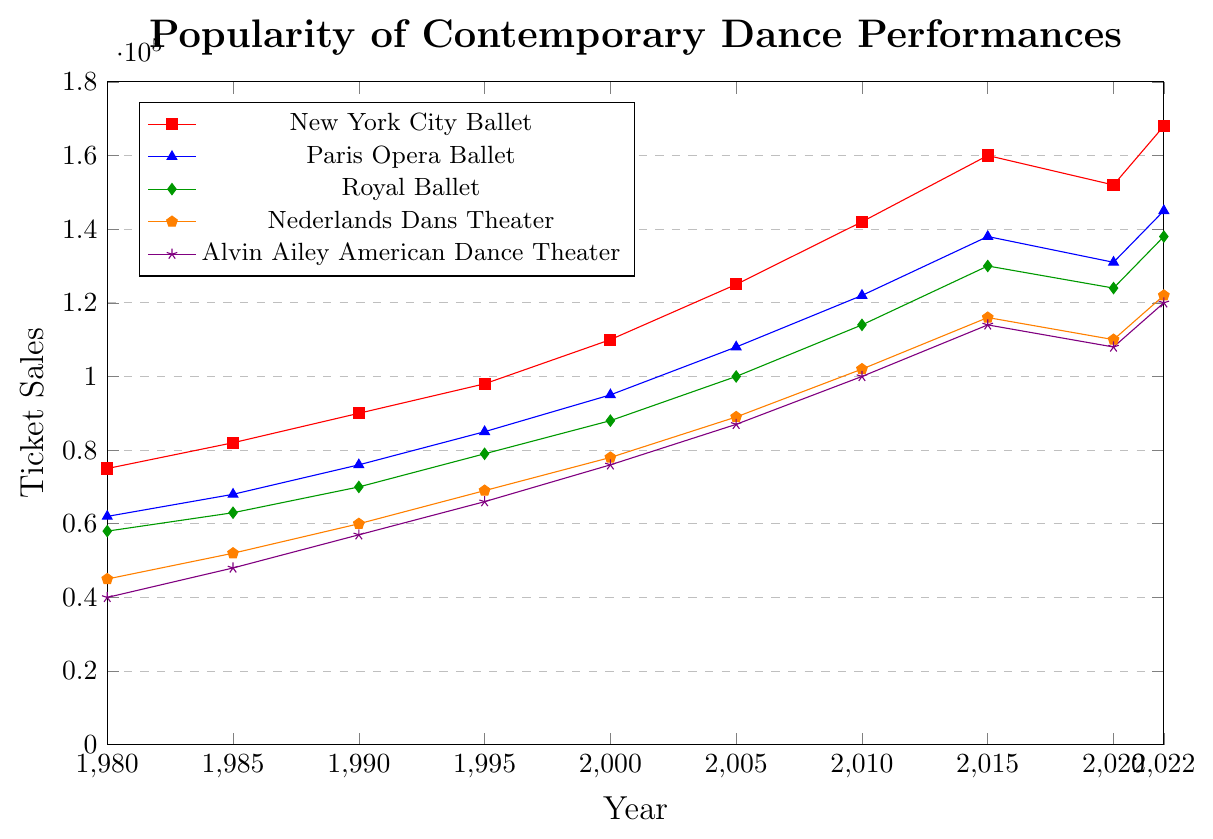What trend can be observed in ticket sales for the New York City Ballet from 1980 to 2022? From 1980 to 2022, the ticket sales for the New York City Ballet show a consistent upward trend except for a slight dip in 2020. Over the years, ticket sales have increased from 75,000 in 1980 to 168,000 in 2022.
Answer: Consistent upward trend Which theater had the highest ticket sales in 2022? Looking at the values for 2022, the New York City Ballet had the highest ticket sales at 168,000.
Answer: New York City Ballet By how much did ticket sales for the Paris Opera Ballet increase from 1980 to 2022? Ticket sales for the Paris Opera Ballet increased from 62,000 in 1980 to 145,000 in 2022. The increase is calculated as 145,000 - 62,000, which equals 83,000.
Answer: 83,000 What are the average ticket sales for Alvin Ailey American Dance Theater from 1980 to 2022? To find the average ticket sales, sum up all ticket sales from 1980 to 2022 (40,000 + 48,000 + 57,000 + 66,000 + 76,000 + 87,000 + 100,000 + 114,000 + 108,000 + 120,000) and divide by the number of years (10). The sum is 816,000, so the average is 816,000 / 10 = 81,600.
Answer: 81,600 Which theaters experienced a decrease in ticket sales from 2015 to 2020? Comparing the ticket sales from 2015 to 2020, the theaters that experienced a decrease are the New York City Ballet (160,000 to 152,000), Paris Opera Ballet (138,000 to 131,000), Royal Ballet (130,000 to 124,000), Nederlands Dans Theater (116,000 to 110,000), and Alvin Ailey American Dance Theater (114,000 to 108,000).
Answer: All theaters By what percentage did the Royal Ballet's ticket sales grow from 2000 to 2010? Ticket sales for the Royal Ballet grew from 88,000 in 2000 to 114,000 in 2010. The growth can be calculated as ((114,000 - 88,000) / 88,000) * 100 = 29.55%.
Answer: 29.55% Which theater’s ticket sales increased the most between 1980 and 2022? Comparing the increase in ticket sales from 1980 to 2022: 
- New York City Ballet: 168,000 - 75,000 = 93,000
- Paris Opera Ballet: 145,000 - 62,000 = 83,000
- Royal Ballet: 138,000 - 58,000 = 80,000
- Nederlands Dans Theater: 122,000 - 45,000 = 77,000
- Alvin Ailey American Dance Theater: 120,000 - 40,000 = 80,000
The New York City Ballet had the highest increase of 93,000.
Answer: New York City Ballet Which theater had the lowest ticket sales in 1980? Looking at the data for 1980, Alvin Ailey American Dance Theater had the lowest ticket sales at 40,000.
Answer: Alvin Ailey American Dance Theater What is the difference in ticket sales between the Paris Opera Ballet and the Royal Ballet in 2015? In 2015, the ticket sales for the Paris Opera Ballet were 138,000, while for the Royal Ballet, it was 130,000. The difference is 138,000 - 130,000 = 8,000.
Answer: 8,000 